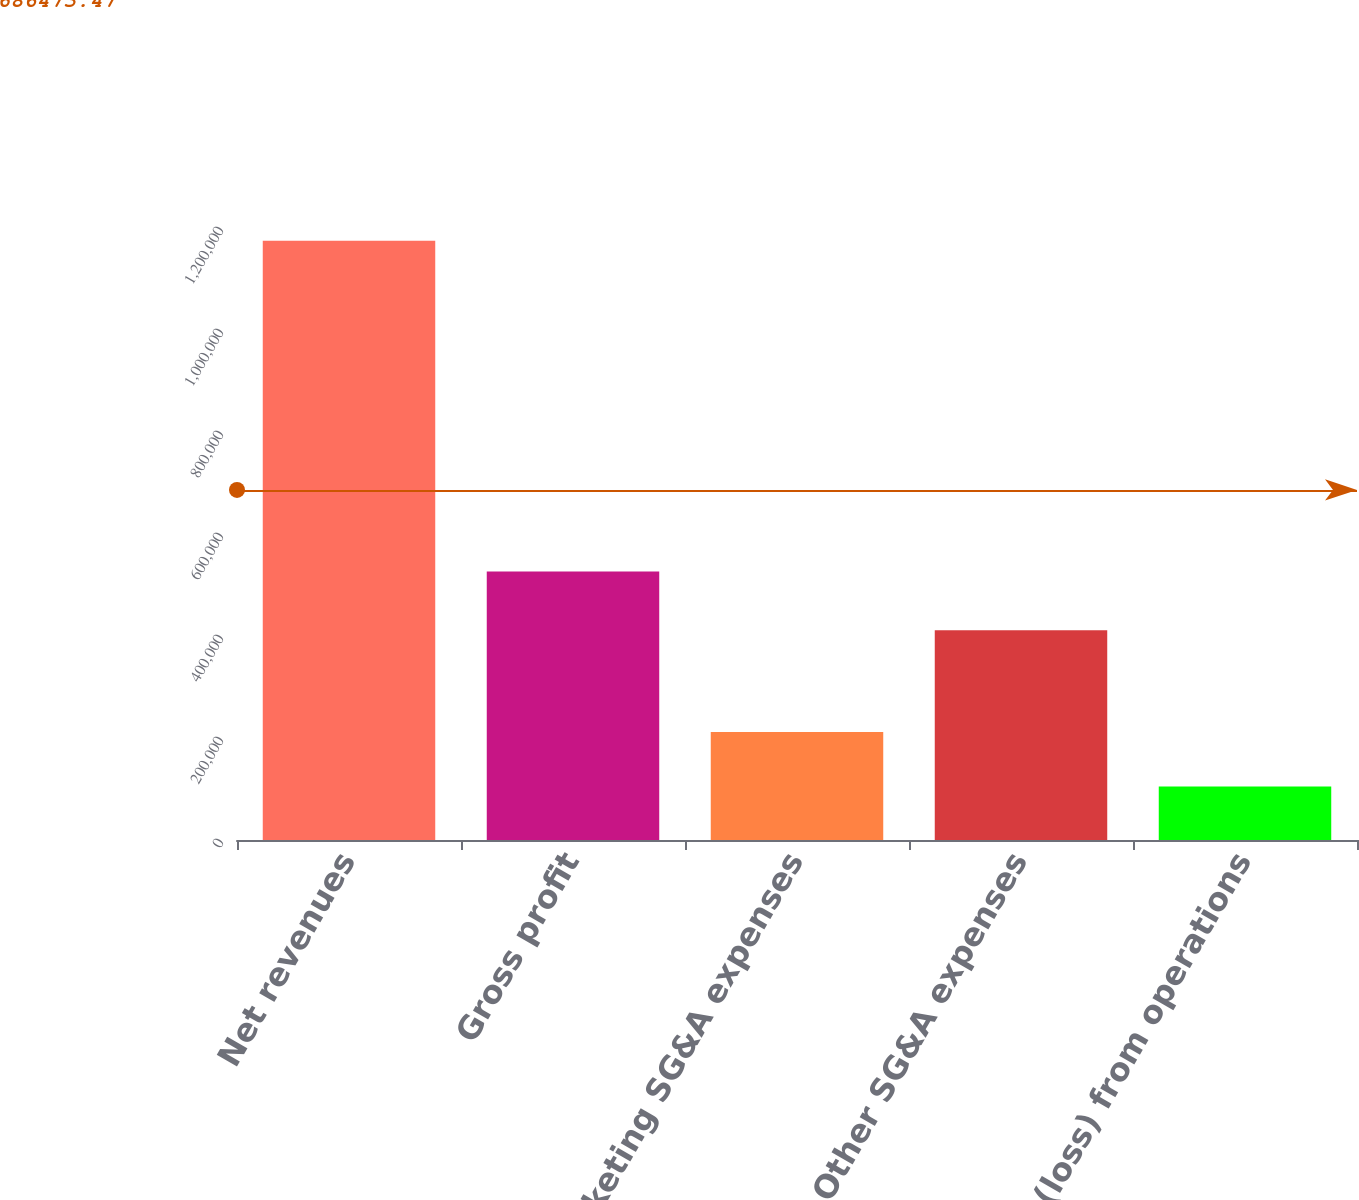Convert chart to OTSL. <chart><loc_0><loc_0><loc_500><loc_500><bar_chart><fcel>Net revenues<fcel>Gross profit<fcel>Marketing SG&A expenses<fcel>Other SG&A expenses<fcel>Income (loss) from operations<nl><fcel>1.17486e+06<fcel>526584<fcel>211873<fcel>411147<fcel>104875<nl></chart> 